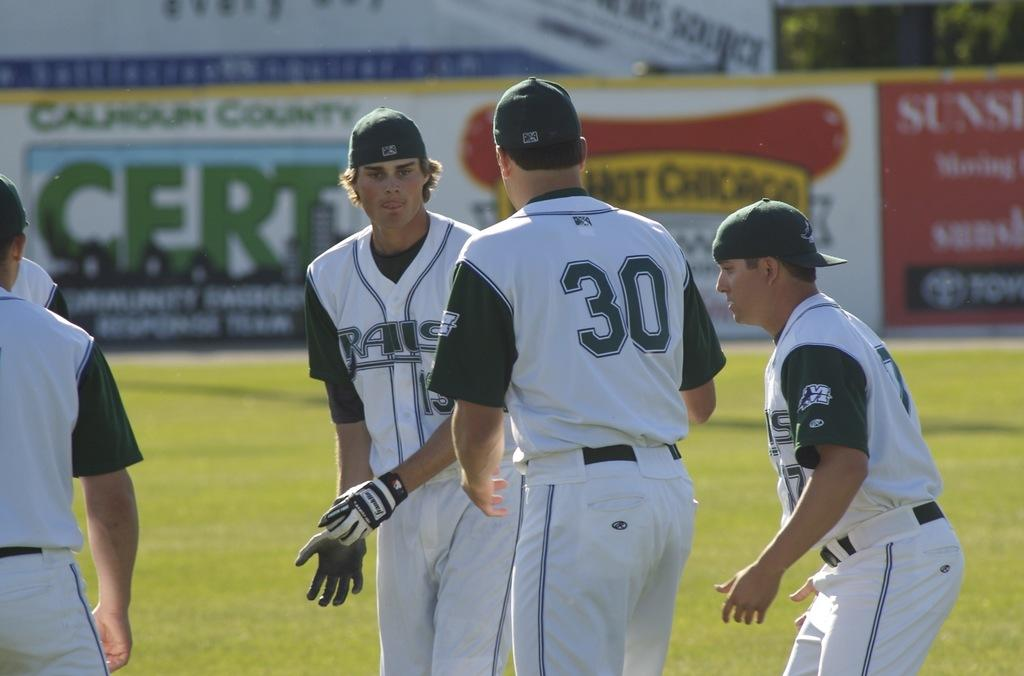<image>
Describe the image concisely. baseball players with one wearing a uniform top that says '30' onit 